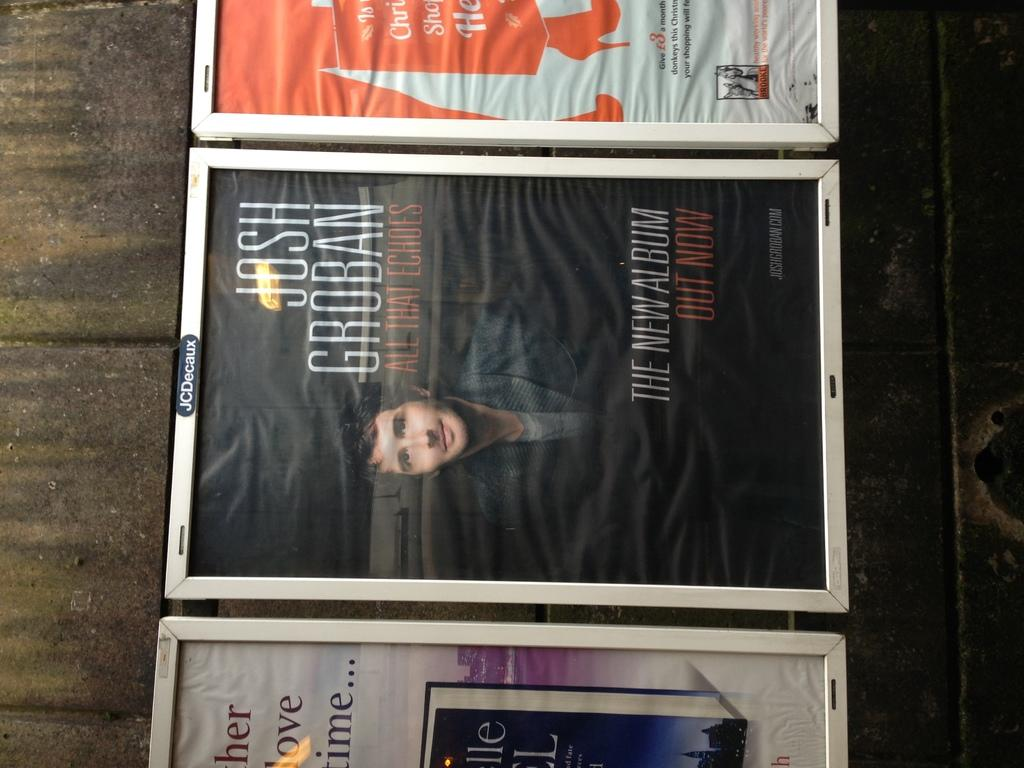What objects are present in the image that hold photographs? There are photo frames in the image that hold photographs. What type of surface are the photo frames placed on? The photo frames are on a wooden surface. Who is depicted in the photographs? The photos in the frames contain images of a person. What additional information is provided on the photographs? There is writing on the photos. What type of roof can be seen in the image? There is no roof visible in the image; the focus is on the photo frames and their contents. 